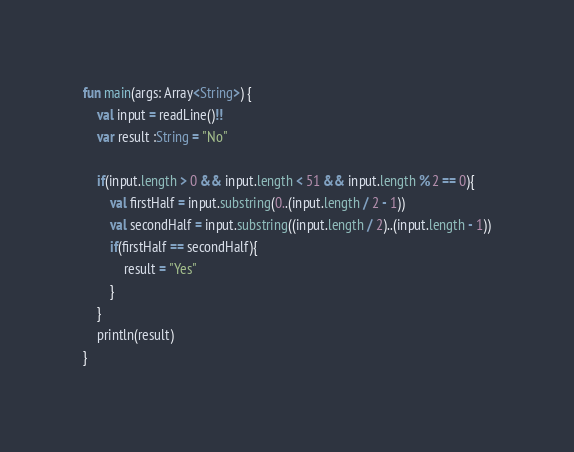Convert code to text. <code><loc_0><loc_0><loc_500><loc_500><_Kotlin_>fun main(args: Array<String>) {
    val input = readLine()!!
    var result :String = "No"

    if(input.length > 0 && input.length < 51 && input.length % 2 == 0){
        val firstHalf = input.substring(0..(input.length / 2 - 1))
        val secondHalf = input.substring((input.length / 2)..(input.length - 1))
        if(firstHalf == secondHalf){
            result = "Yes"
        }
    }
    println(result)
}</code> 